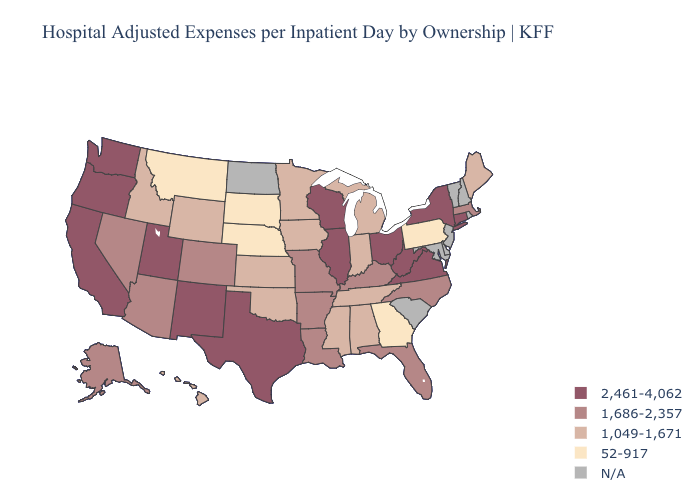How many symbols are there in the legend?
Give a very brief answer. 5. Which states have the highest value in the USA?
Give a very brief answer. California, Connecticut, Illinois, New Mexico, New York, Ohio, Oregon, Texas, Utah, Virginia, Washington, West Virginia, Wisconsin. Name the states that have a value in the range 1,686-2,357?
Concise answer only. Alaska, Arizona, Arkansas, Colorado, Florida, Kentucky, Louisiana, Massachusetts, Missouri, Nevada, North Carolina. What is the highest value in states that border Montana?
Quick response, please. 1,049-1,671. What is the value of West Virginia?
Be succinct. 2,461-4,062. What is the value of New Mexico?
Write a very short answer. 2,461-4,062. How many symbols are there in the legend?
Short answer required. 5. How many symbols are there in the legend?
Answer briefly. 5. Name the states that have a value in the range 1,686-2,357?
Keep it brief. Alaska, Arizona, Arkansas, Colorado, Florida, Kentucky, Louisiana, Massachusetts, Missouri, Nevada, North Carolina. What is the value of North Dakota?
Concise answer only. N/A. Does the map have missing data?
Be succinct. Yes. Which states hav the highest value in the West?
Give a very brief answer. California, New Mexico, Oregon, Utah, Washington. What is the value of Iowa?
Short answer required. 1,049-1,671. 